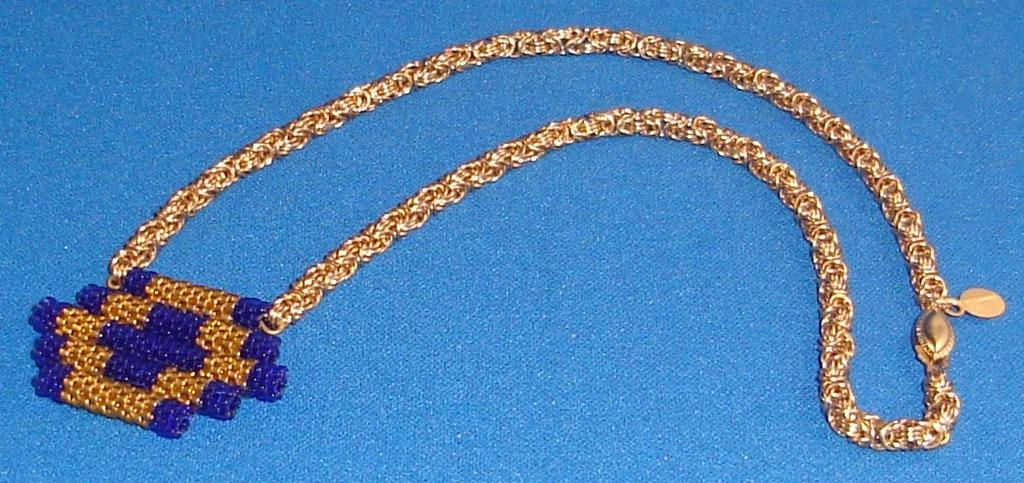What is the main object in the image? There is a chain in the image. Where is the chain located? The chain is on a surface. Is there anything attached to the chain? Yes, there is a pendant attached to the chain. How many legs does the pendant have in the image? The pendant does not have legs; it is an accessory attached to the chain. 